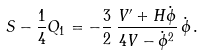Convert formula to latex. <formula><loc_0><loc_0><loc_500><loc_500>\ S - \frac { 1 } { 4 } Q _ { 1 } = - \frac { 3 } { 2 } \, \frac { V ^ { \prime } + H \dot { \phi } } { 4 V - \dot { \phi } ^ { 2 } } \, \dot { \phi } \, .</formula> 